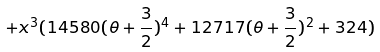<formula> <loc_0><loc_0><loc_500><loc_500>+ x ^ { 3 } ( 1 4 5 8 0 ( \theta + \frac { 3 } { 2 } ) ^ { 4 } + 1 2 7 1 7 ( \theta + \frac { 3 } { 2 } ) ^ { 2 } + 3 2 4 )</formula> 